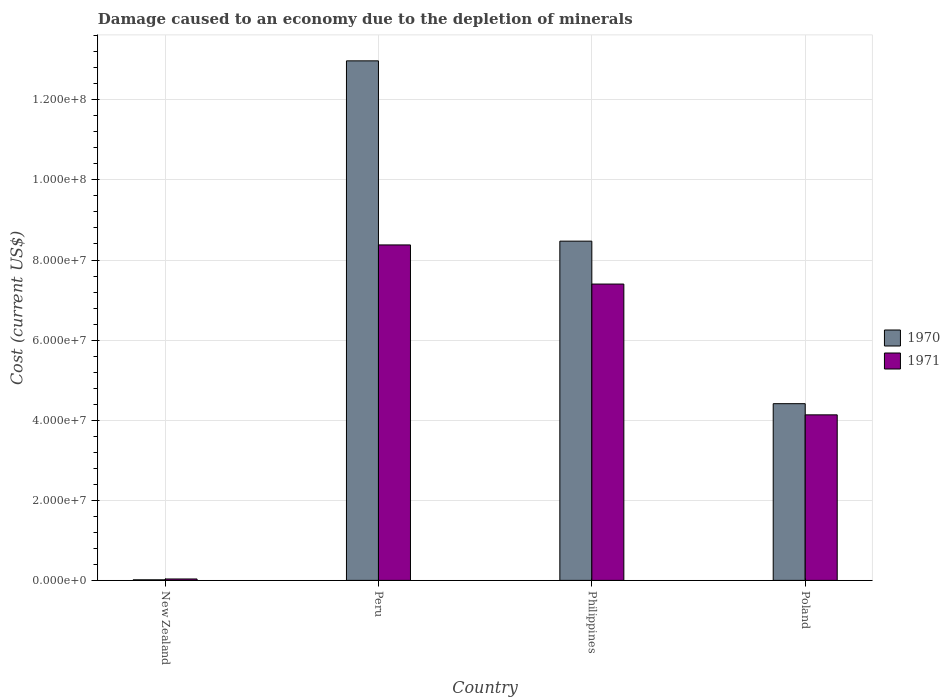How many different coloured bars are there?
Make the answer very short. 2. Are the number of bars on each tick of the X-axis equal?
Provide a short and direct response. Yes. How many bars are there on the 2nd tick from the right?
Your answer should be very brief. 2. What is the cost of damage caused due to the depletion of minerals in 1970 in Philippines?
Give a very brief answer. 8.47e+07. Across all countries, what is the maximum cost of damage caused due to the depletion of minerals in 1971?
Provide a short and direct response. 8.38e+07. Across all countries, what is the minimum cost of damage caused due to the depletion of minerals in 1971?
Make the answer very short. 3.55e+05. In which country was the cost of damage caused due to the depletion of minerals in 1971 maximum?
Provide a succinct answer. Peru. In which country was the cost of damage caused due to the depletion of minerals in 1971 minimum?
Your answer should be compact. New Zealand. What is the total cost of damage caused due to the depletion of minerals in 1971 in the graph?
Keep it short and to the point. 1.99e+08. What is the difference between the cost of damage caused due to the depletion of minerals in 1970 in New Zealand and that in Poland?
Ensure brevity in your answer.  -4.40e+07. What is the difference between the cost of damage caused due to the depletion of minerals in 1970 in Poland and the cost of damage caused due to the depletion of minerals in 1971 in Philippines?
Your response must be concise. -2.99e+07. What is the average cost of damage caused due to the depletion of minerals in 1971 per country?
Offer a terse response. 4.99e+07. What is the difference between the cost of damage caused due to the depletion of minerals of/in 1971 and cost of damage caused due to the depletion of minerals of/in 1970 in Poland?
Keep it short and to the point. -2.79e+06. In how many countries, is the cost of damage caused due to the depletion of minerals in 1971 greater than 124000000 US$?
Provide a short and direct response. 0. What is the ratio of the cost of damage caused due to the depletion of minerals in 1971 in Peru to that in Philippines?
Ensure brevity in your answer.  1.13. Is the cost of damage caused due to the depletion of minerals in 1971 in New Zealand less than that in Peru?
Offer a terse response. Yes. What is the difference between the highest and the second highest cost of damage caused due to the depletion of minerals in 1970?
Provide a succinct answer. -4.50e+07. What is the difference between the highest and the lowest cost of damage caused due to the depletion of minerals in 1970?
Your answer should be compact. 1.30e+08. What does the 2nd bar from the right in Poland represents?
Your answer should be very brief. 1970. How many bars are there?
Provide a succinct answer. 8. Are all the bars in the graph horizontal?
Offer a very short reply. No. How many countries are there in the graph?
Your response must be concise. 4. What is the difference between two consecutive major ticks on the Y-axis?
Make the answer very short. 2.00e+07. Are the values on the major ticks of Y-axis written in scientific E-notation?
Keep it short and to the point. Yes. Does the graph contain any zero values?
Provide a short and direct response. No. Where does the legend appear in the graph?
Your answer should be compact. Center right. How many legend labels are there?
Your answer should be very brief. 2. What is the title of the graph?
Ensure brevity in your answer.  Damage caused to an economy due to the depletion of minerals. Does "1974" appear as one of the legend labels in the graph?
Keep it short and to the point. No. What is the label or title of the X-axis?
Offer a terse response. Country. What is the label or title of the Y-axis?
Your response must be concise. Cost (current US$). What is the Cost (current US$) in 1970 in New Zealand?
Make the answer very short. 1.43e+05. What is the Cost (current US$) of 1971 in New Zealand?
Keep it short and to the point. 3.55e+05. What is the Cost (current US$) of 1970 in Peru?
Ensure brevity in your answer.  1.30e+08. What is the Cost (current US$) in 1971 in Peru?
Offer a very short reply. 8.38e+07. What is the Cost (current US$) in 1970 in Philippines?
Ensure brevity in your answer.  8.47e+07. What is the Cost (current US$) of 1971 in Philippines?
Ensure brevity in your answer.  7.40e+07. What is the Cost (current US$) of 1970 in Poland?
Your answer should be compact. 4.41e+07. What is the Cost (current US$) of 1971 in Poland?
Offer a terse response. 4.13e+07. Across all countries, what is the maximum Cost (current US$) of 1970?
Make the answer very short. 1.30e+08. Across all countries, what is the maximum Cost (current US$) of 1971?
Provide a short and direct response. 8.38e+07. Across all countries, what is the minimum Cost (current US$) of 1970?
Make the answer very short. 1.43e+05. Across all countries, what is the minimum Cost (current US$) in 1971?
Make the answer very short. 3.55e+05. What is the total Cost (current US$) in 1970 in the graph?
Provide a succinct answer. 2.59e+08. What is the total Cost (current US$) in 1971 in the graph?
Provide a short and direct response. 1.99e+08. What is the difference between the Cost (current US$) in 1970 in New Zealand and that in Peru?
Your answer should be very brief. -1.30e+08. What is the difference between the Cost (current US$) in 1971 in New Zealand and that in Peru?
Ensure brevity in your answer.  -8.34e+07. What is the difference between the Cost (current US$) in 1970 in New Zealand and that in Philippines?
Make the answer very short. -8.46e+07. What is the difference between the Cost (current US$) in 1971 in New Zealand and that in Philippines?
Your answer should be very brief. -7.36e+07. What is the difference between the Cost (current US$) in 1970 in New Zealand and that in Poland?
Give a very brief answer. -4.40e+07. What is the difference between the Cost (current US$) of 1971 in New Zealand and that in Poland?
Give a very brief answer. -4.10e+07. What is the difference between the Cost (current US$) in 1970 in Peru and that in Philippines?
Offer a very short reply. 4.50e+07. What is the difference between the Cost (current US$) of 1971 in Peru and that in Philippines?
Make the answer very short. 9.77e+06. What is the difference between the Cost (current US$) of 1970 in Peru and that in Poland?
Offer a very short reply. 8.56e+07. What is the difference between the Cost (current US$) of 1971 in Peru and that in Poland?
Offer a terse response. 4.24e+07. What is the difference between the Cost (current US$) of 1970 in Philippines and that in Poland?
Offer a terse response. 4.06e+07. What is the difference between the Cost (current US$) of 1971 in Philippines and that in Poland?
Give a very brief answer. 3.27e+07. What is the difference between the Cost (current US$) in 1970 in New Zealand and the Cost (current US$) in 1971 in Peru?
Make the answer very short. -8.36e+07. What is the difference between the Cost (current US$) in 1970 in New Zealand and the Cost (current US$) in 1971 in Philippines?
Keep it short and to the point. -7.39e+07. What is the difference between the Cost (current US$) in 1970 in New Zealand and the Cost (current US$) in 1971 in Poland?
Provide a short and direct response. -4.12e+07. What is the difference between the Cost (current US$) in 1970 in Peru and the Cost (current US$) in 1971 in Philippines?
Give a very brief answer. 5.57e+07. What is the difference between the Cost (current US$) of 1970 in Peru and the Cost (current US$) of 1971 in Poland?
Offer a terse response. 8.84e+07. What is the difference between the Cost (current US$) of 1970 in Philippines and the Cost (current US$) of 1971 in Poland?
Offer a very short reply. 4.34e+07. What is the average Cost (current US$) of 1970 per country?
Your response must be concise. 6.47e+07. What is the average Cost (current US$) of 1971 per country?
Your answer should be compact. 4.99e+07. What is the difference between the Cost (current US$) of 1970 and Cost (current US$) of 1971 in New Zealand?
Give a very brief answer. -2.11e+05. What is the difference between the Cost (current US$) in 1970 and Cost (current US$) in 1971 in Peru?
Keep it short and to the point. 4.60e+07. What is the difference between the Cost (current US$) in 1970 and Cost (current US$) in 1971 in Philippines?
Offer a very short reply. 1.07e+07. What is the difference between the Cost (current US$) in 1970 and Cost (current US$) in 1971 in Poland?
Your response must be concise. 2.79e+06. What is the ratio of the Cost (current US$) of 1970 in New Zealand to that in Peru?
Your answer should be compact. 0. What is the ratio of the Cost (current US$) of 1971 in New Zealand to that in Peru?
Keep it short and to the point. 0. What is the ratio of the Cost (current US$) in 1970 in New Zealand to that in Philippines?
Provide a succinct answer. 0. What is the ratio of the Cost (current US$) in 1971 in New Zealand to that in Philippines?
Offer a very short reply. 0. What is the ratio of the Cost (current US$) of 1970 in New Zealand to that in Poland?
Give a very brief answer. 0. What is the ratio of the Cost (current US$) of 1971 in New Zealand to that in Poland?
Give a very brief answer. 0.01. What is the ratio of the Cost (current US$) in 1970 in Peru to that in Philippines?
Your response must be concise. 1.53. What is the ratio of the Cost (current US$) in 1971 in Peru to that in Philippines?
Your answer should be compact. 1.13. What is the ratio of the Cost (current US$) in 1970 in Peru to that in Poland?
Ensure brevity in your answer.  2.94. What is the ratio of the Cost (current US$) in 1971 in Peru to that in Poland?
Your answer should be compact. 2.03. What is the ratio of the Cost (current US$) of 1970 in Philippines to that in Poland?
Keep it short and to the point. 1.92. What is the ratio of the Cost (current US$) in 1971 in Philippines to that in Poland?
Ensure brevity in your answer.  1.79. What is the difference between the highest and the second highest Cost (current US$) in 1970?
Ensure brevity in your answer.  4.50e+07. What is the difference between the highest and the second highest Cost (current US$) in 1971?
Offer a very short reply. 9.77e+06. What is the difference between the highest and the lowest Cost (current US$) of 1970?
Your answer should be very brief. 1.30e+08. What is the difference between the highest and the lowest Cost (current US$) in 1971?
Provide a succinct answer. 8.34e+07. 